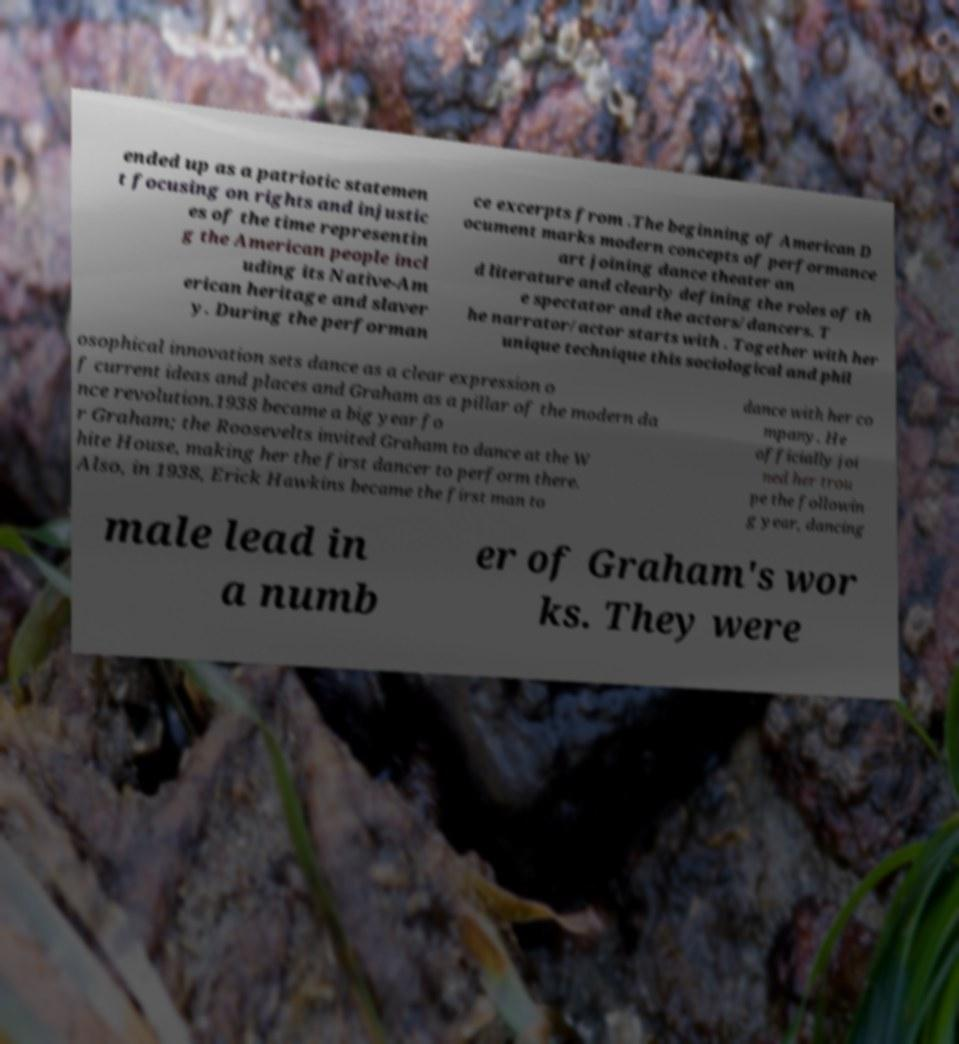For documentation purposes, I need the text within this image transcribed. Could you provide that? ended up as a patriotic statemen t focusing on rights and injustic es of the time representin g the American people incl uding its Native-Am erican heritage and slaver y. During the performan ce excerpts from .The beginning of American D ocument marks modern concepts of performance art joining dance theater an d literature and clearly defining the roles of th e spectator and the actors/dancers. T he narrator/actor starts with . Together with her unique technique this sociological and phil osophical innovation sets dance as a clear expression o f current ideas and places and Graham as a pillar of the modern da nce revolution.1938 became a big year fo r Graham; the Roosevelts invited Graham to dance at the W hite House, making her the first dancer to perform there. Also, in 1938, Erick Hawkins became the first man to dance with her co mpany. He officially joi ned her trou pe the followin g year, dancing male lead in a numb er of Graham's wor ks. They were 